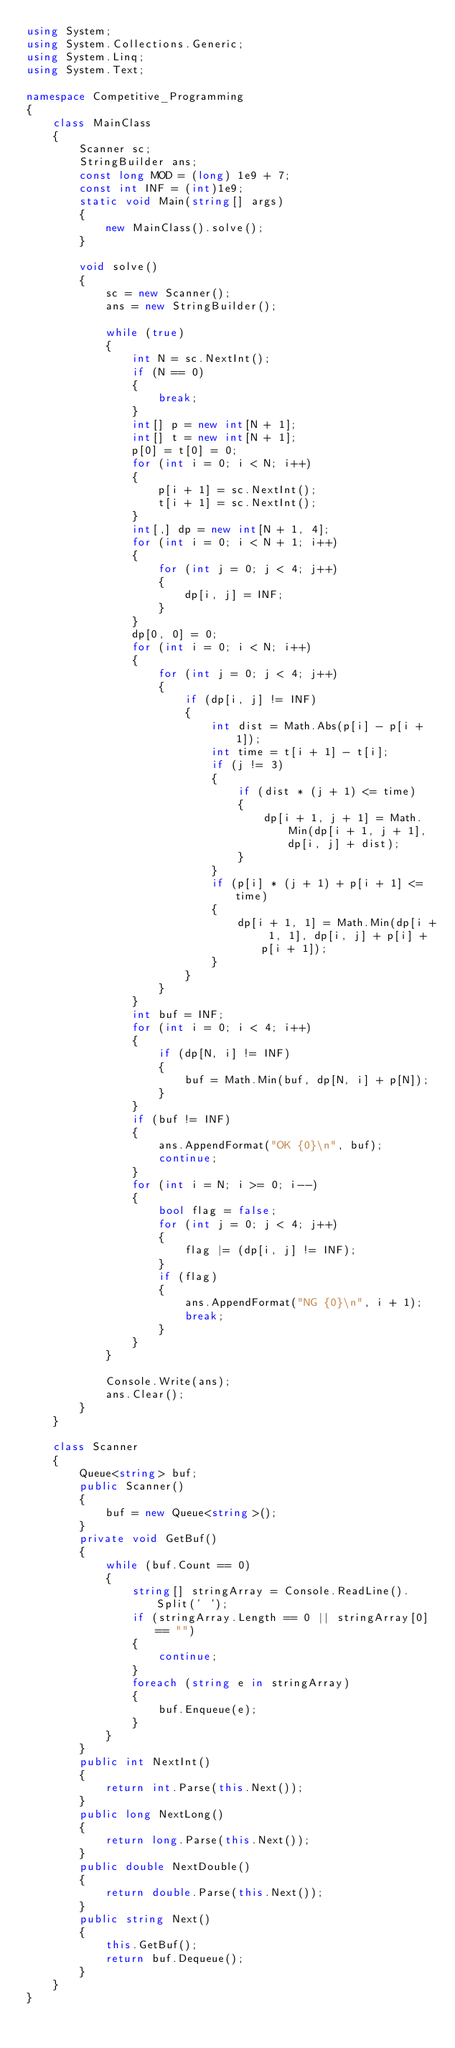<code> <loc_0><loc_0><loc_500><loc_500><_C#_>using System;
using System.Collections.Generic;
using System.Linq;
using System.Text;

namespace Competitive_Programming
{
    class MainClass
    {
        Scanner sc;
        StringBuilder ans;
        const long MOD = (long) 1e9 + 7;
        const int INF = (int)1e9;
        static void Main(string[] args)
        {
            new MainClass().solve();
        }
        
        void solve()
        {
            sc = new Scanner();
            ans = new StringBuilder();
            
            while (true)
            {
                int N = sc.NextInt();
                if (N == 0)
                {
                    break;
                }
                int[] p = new int[N + 1];
                int[] t = new int[N + 1];
                p[0] = t[0] = 0;
                for (int i = 0; i < N; i++)
                {
                    p[i + 1] = sc.NextInt();
                    t[i + 1] = sc.NextInt();
                }
                int[,] dp = new int[N + 1, 4];
                for (int i = 0; i < N + 1; i++)
                {
                    for (int j = 0; j < 4; j++)
                    {
                        dp[i, j] = INF;
                    }
                }
                dp[0, 0] = 0;
                for (int i = 0; i < N; i++)
                {
                    for (int j = 0; j < 4; j++)
                    {
                        if (dp[i, j] != INF)
                        {
                            int dist = Math.Abs(p[i] - p[i + 1]);
                            int time = t[i + 1] - t[i];
                            if (j != 3)
                            {
                                if (dist * (j + 1) <= time)
                                {
                                    dp[i + 1, j + 1] = Math.Min(dp[i + 1, j + 1], dp[i, j] + dist);
                                }
                            }
                            if (p[i] * (j + 1) + p[i + 1] <= time)
                            {
                                dp[i + 1, 1] = Math.Min(dp[i + 1, 1], dp[i, j] + p[i] + p[i + 1]);
                            }
                        }
                    }
                }
                int buf = INF;
                for (int i = 0; i < 4; i++)
                {
                    if (dp[N, i] != INF)
                    {
                        buf = Math.Min(buf, dp[N, i] + p[N]);
                    }
                }
                if (buf != INF)
                {
                    ans.AppendFormat("OK {0}\n", buf);
                    continue;
                }
                for (int i = N; i >= 0; i--)
                {
                    bool flag = false;
                    for (int j = 0; j < 4; j++)
                    {
                        flag |= (dp[i, j] != INF);
                    }
                    if (flag)
                    {
                        ans.AppendFormat("NG {0}\n", i + 1);
                        break;
                    }
                }
            }
            
            Console.Write(ans);
            ans.Clear();
        }
    }
    
    class Scanner
    {
        Queue<string> buf;
        public Scanner()
        {
            buf = new Queue<string>();
        }
        private void GetBuf()
        {
            while (buf.Count == 0)
            {
                string[] stringArray = Console.ReadLine().Split(' ');
                if (stringArray.Length == 0 || stringArray[0] == "")
                {
                    continue;
                }
                foreach (string e in stringArray)
                {
                    buf.Enqueue(e);
                }
            }
        }
        public int NextInt()
        {
            return int.Parse(this.Next());
        }
        public long NextLong()
        {
            return long.Parse(this.Next());
        }
        public double NextDouble()
        {
            return double.Parse(this.Next());
        }
        public string Next()
        {
            this.GetBuf();
            return buf.Dequeue();
        }
    }
}</code> 